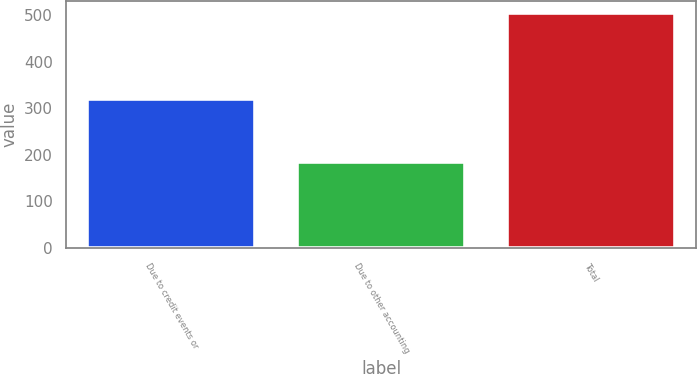Convert chart. <chart><loc_0><loc_0><loc_500><loc_500><bar_chart><fcel>Due to credit events or<fcel>Due to other accounting<fcel>Total<nl><fcel>321<fcel>185<fcel>506<nl></chart> 